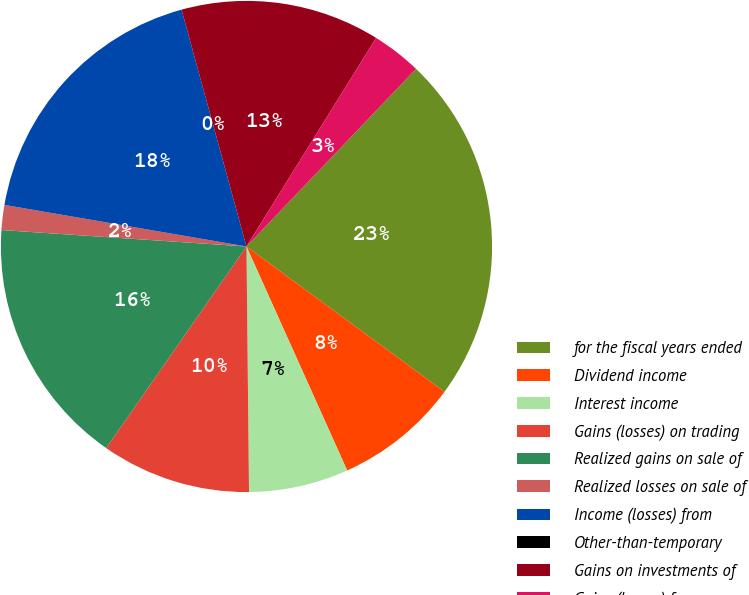Convert chart. <chart><loc_0><loc_0><loc_500><loc_500><pie_chart><fcel>for the fiscal years ended<fcel>Dividend income<fcel>Interest income<fcel>Gains (losses) on trading<fcel>Realized gains on sale of<fcel>Realized losses on sale of<fcel>Income (losses) from<fcel>Other-than-temporary<fcel>Gains on investments of<fcel>Gains (losses) from<nl><fcel>22.94%<fcel>8.2%<fcel>6.56%<fcel>9.84%<fcel>16.39%<fcel>1.64%<fcel>18.03%<fcel>0.0%<fcel>13.11%<fcel>3.28%<nl></chart> 